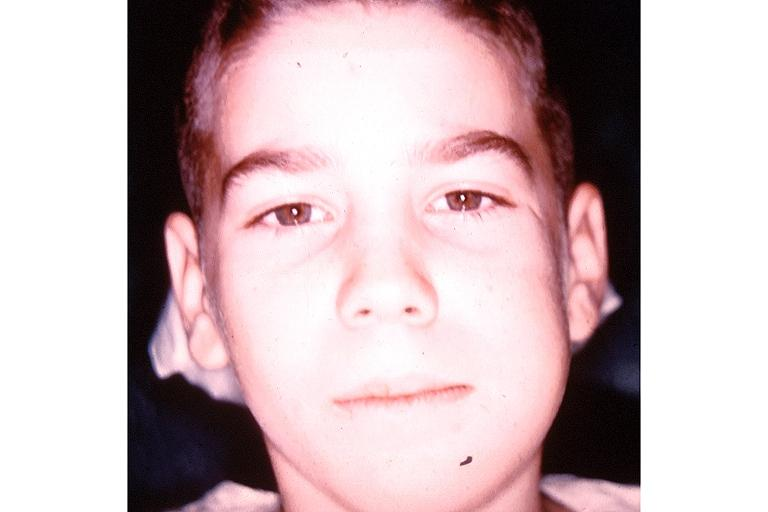does this image show garres osteomyelitis proliferative periosteitis?
Answer the question using a single word or phrase. Yes 